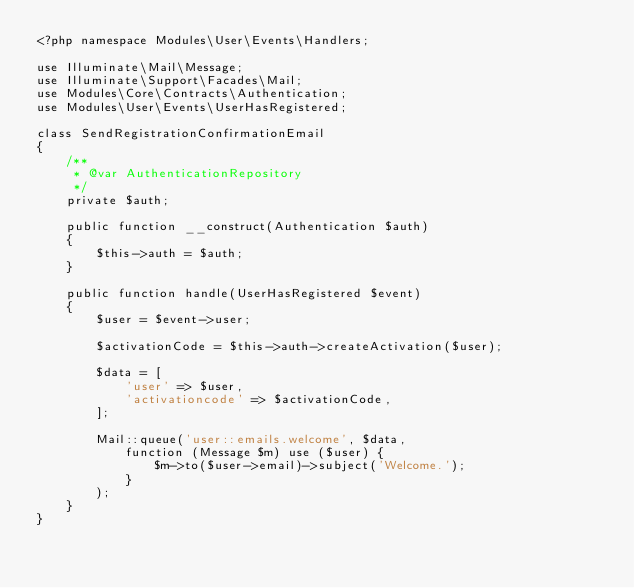Convert code to text. <code><loc_0><loc_0><loc_500><loc_500><_PHP_><?php namespace Modules\User\Events\Handlers;

use Illuminate\Mail\Message;
use Illuminate\Support\Facades\Mail;
use Modules\Core\Contracts\Authentication;
use Modules\User\Events\UserHasRegistered;

class SendRegistrationConfirmationEmail
{
    /**
     * @var AuthenticationRepository
     */
    private $auth;

    public function __construct(Authentication $auth)
    {
        $this->auth = $auth;
    }

    public function handle(UserHasRegistered $event)
    {
        $user = $event->user;

        $activationCode = $this->auth->createActivation($user);

        $data = [
            'user' => $user,
            'activationcode' => $activationCode,
        ];

        Mail::queue('user::emails.welcome', $data,
            function (Message $m) use ($user) {
                $m->to($user->email)->subject('Welcome.');
            }
        );
    }
}
</code> 